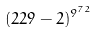<formula> <loc_0><loc_0><loc_500><loc_500>( 2 2 9 - 2 ) ^ { 9 ^ { 7 2 } }</formula> 